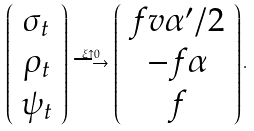<formula> <loc_0><loc_0><loc_500><loc_500>\left ( \begin{array} { c } \sigma _ { t } \\ \rho _ { t } \\ \psi _ { t } \end{array} \right ) \stackrel { \xi \uparrow 0 } { \longrightarrow } \left ( \begin{array} { c } f v \alpha ^ { \prime } / 2 \\ - f \alpha \\ f \end{array} \right ) .</formula> 